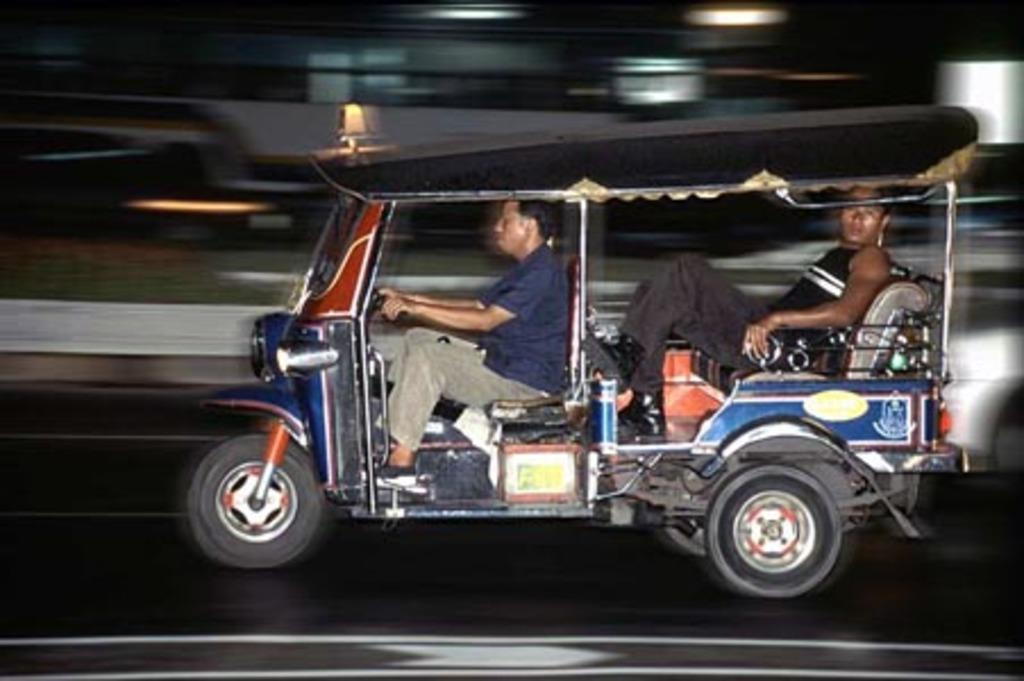What is the main subject of the image? There is a vehicle on the road in the image. Can you describe the occupants of the vehicle? There are two people inside the vehicle. What can be said about the background of the image? The background of the image is blurry. What type of tooth is visible in the image? There is no tooth visible in the image. What observation can be made about the bait in the image? There is no bait present in the image. 